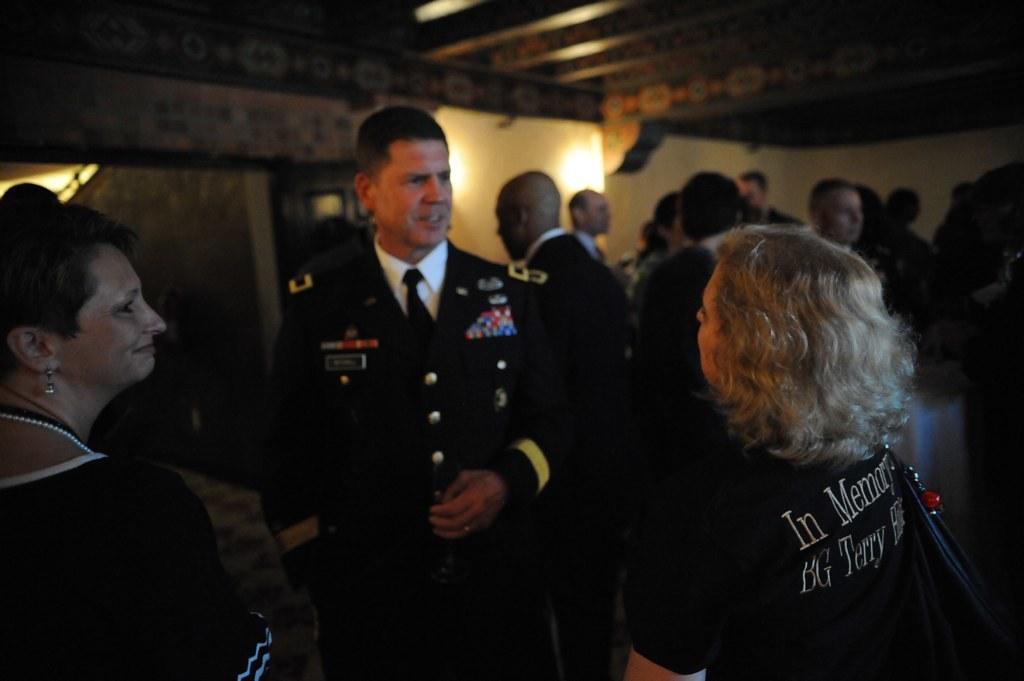Describe this image in one or two sentences. In this image we can see the people standing. On the right there is a woman wearing the bag. In the background we can see the wall and also the lights. At the top we can see the roof for shelter. 